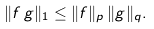Convert formula to latex. <formula><loc_0><loc_0><loc_500><loc_500>\| f \, g \| _ { 1 } \leq \| f \| _ { p } \, \| g \| _ { q } .</formula> 